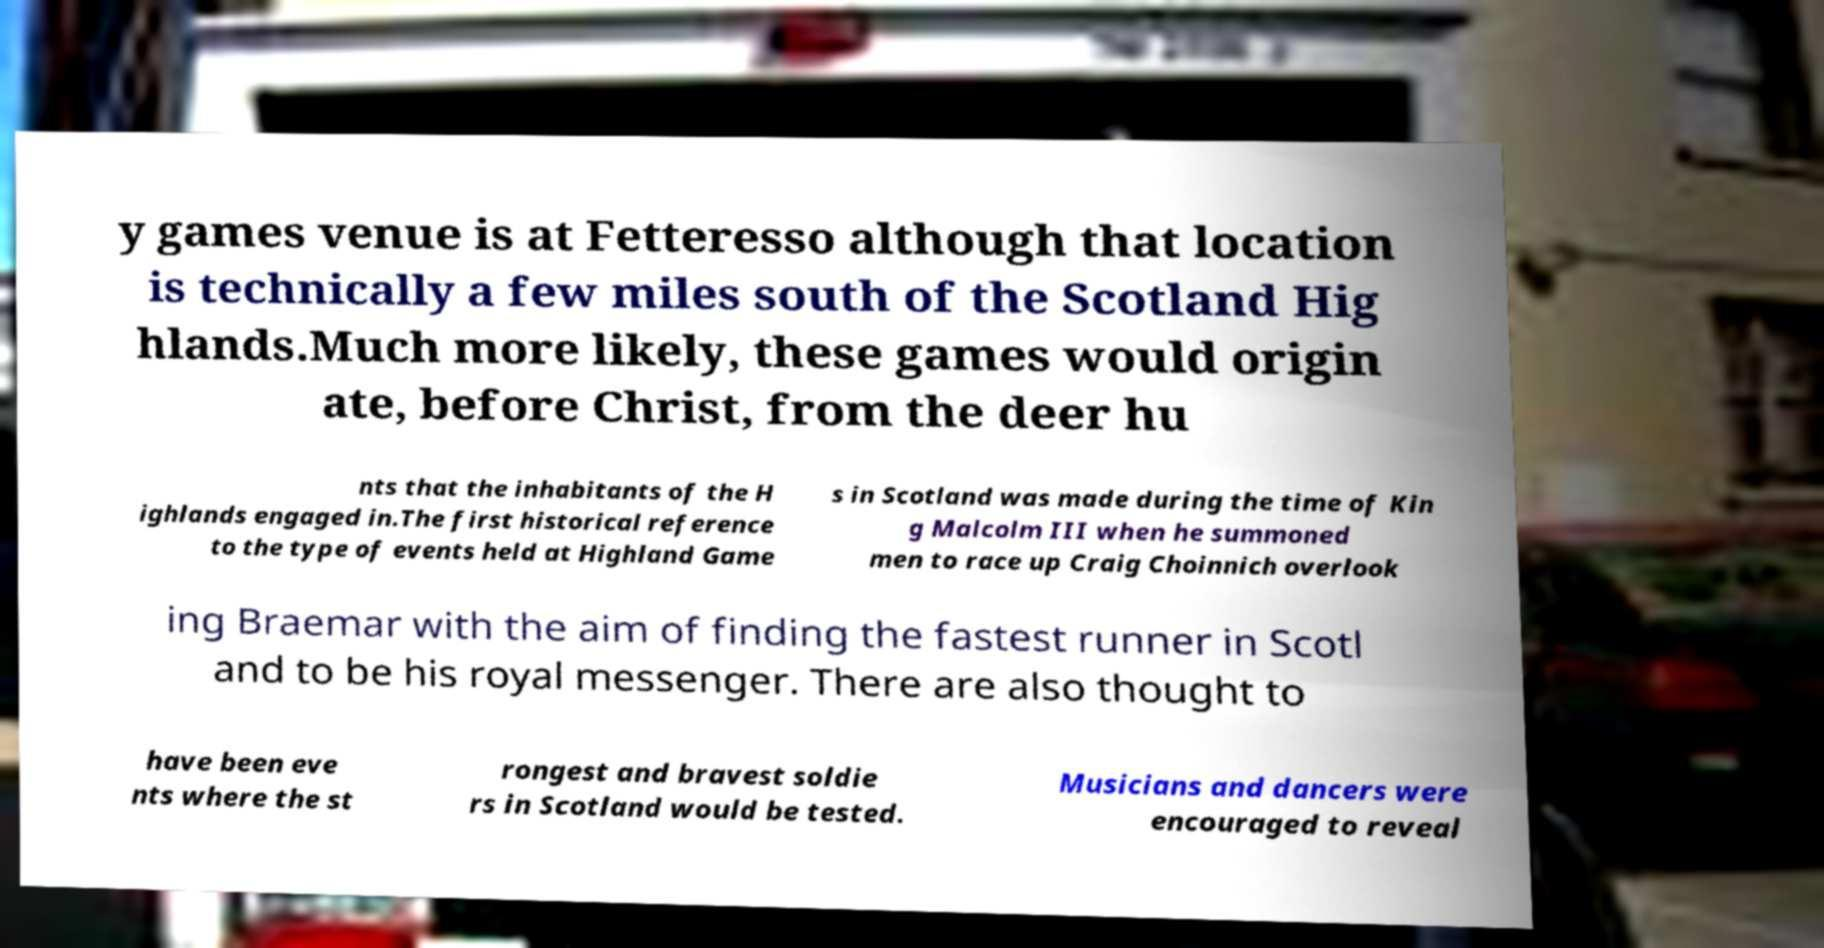What messages or text are displayed in this image? I need them in a readable, typed format. y games venue is at Fetteresso although that location is technically a few miles south of the Scotland Hig hlands.Much more likely, these games would origin ate, before Christ, from the deer hu nts that the inhabitants of the H ighlands engaged in.The first historical reference to the type of events held at Highland Game s in Scotland was made during the time of Kin g Malcolm III when he summoned men to race up Craig Choinnich overlook ing Braemar with the aim of finding the fastest runner in Scotl and to be his royal messenger. There are also thought to have been eve nts where the st rongest and bravest soldie rs in Scotland would be tested. Musicians and dancers were encouraged to reveal 